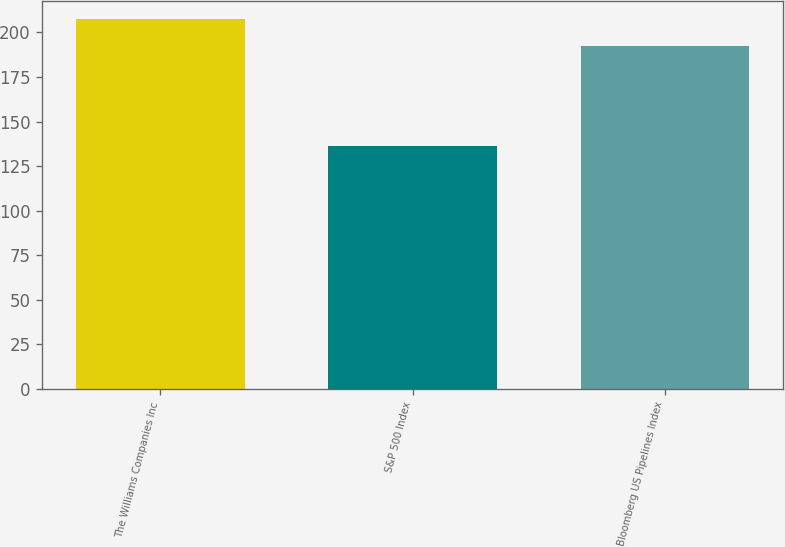Convert chart. <chart><loc_0><loc_0><loc_500><loc_500><bar_chart><fcel>The Williams Companies Inc<fcel>S&P 500 Index<fcel>Bloomberg US Pipelines Index<nl><fcel>207.5<fcel>136.2<fcel>192.4<nl></chart> 